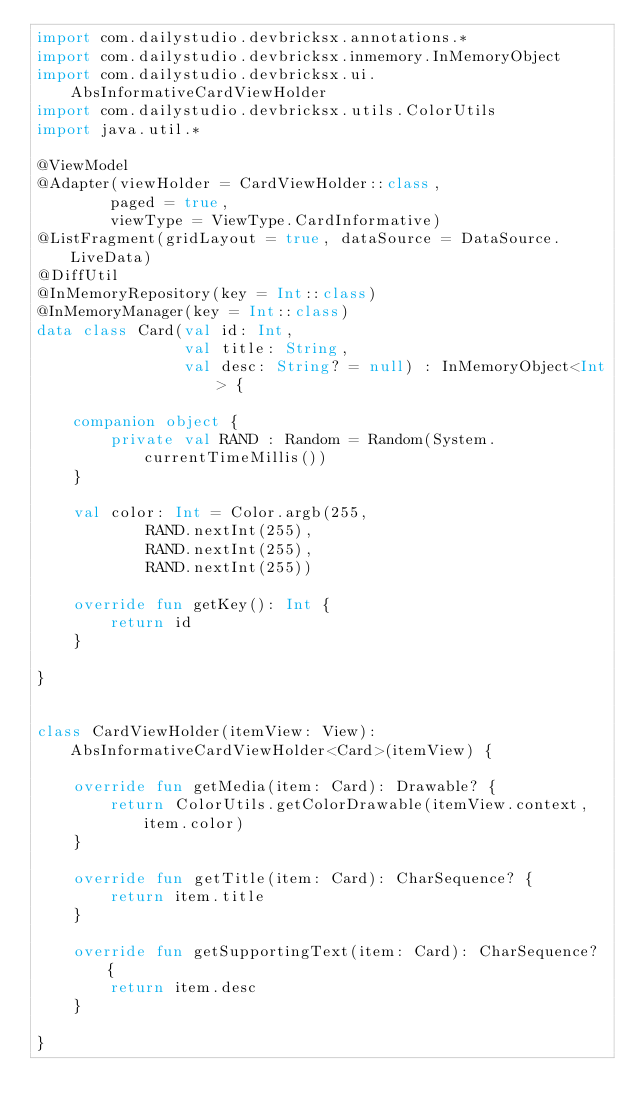Convert code to text. <code><loc_0><loc_0><loc_500><loc_500><_Kotlin_>import com.dailystudio.devbricksx.annotations.*
import com.dailystudio.devbricksx.inmemory.InMemoryObject
import com.dailystudio.devbricksx.ui.AbsInformativeCardViewHolder
import com.dailystudio.devbricksx.utils.ColorUtils
import java.util.*

@ViewModel
@Adapter(viewHolder = CardViewHolder::class,
        paged = true,
        viewType = ViewType.CardInformative)
@ListFragment(gridLayout = true, dataSource = DataSource.LiveData)
@DiffUtil
@InMemoryRepository(key = Int::class)
@InMemoryManager(key = Int::class)
data class Card(val id: Int,
                val title: String,
                val desc: String? = null) : InMemoryObject<Int> {

    companion object {
        private val RAND : Random = Random(System.currentTimeMillis())
    }

    val color: Int = Color.argb(255,
            RAND.nextInt(255),
            RAND.nextInt(255),
            RAND.nextInt(255))

    override fun getKey(): Int {
        return id
    }

}


class CardViewHolder(itemView: View): AbsInformativeCardViewHolder<Card>(itemView) {

    override fun getMedia(item: Card): Drawable? {
        return ColorUtils.getColorDrawable(itemView.context, item.color)
    }

    override fun getTitle(item: Card): CharSequence? {
        return item.title
    }

    override fun getSupportingText(item: Card): CharSequence? {
        return item.desc
    }

}</code> 